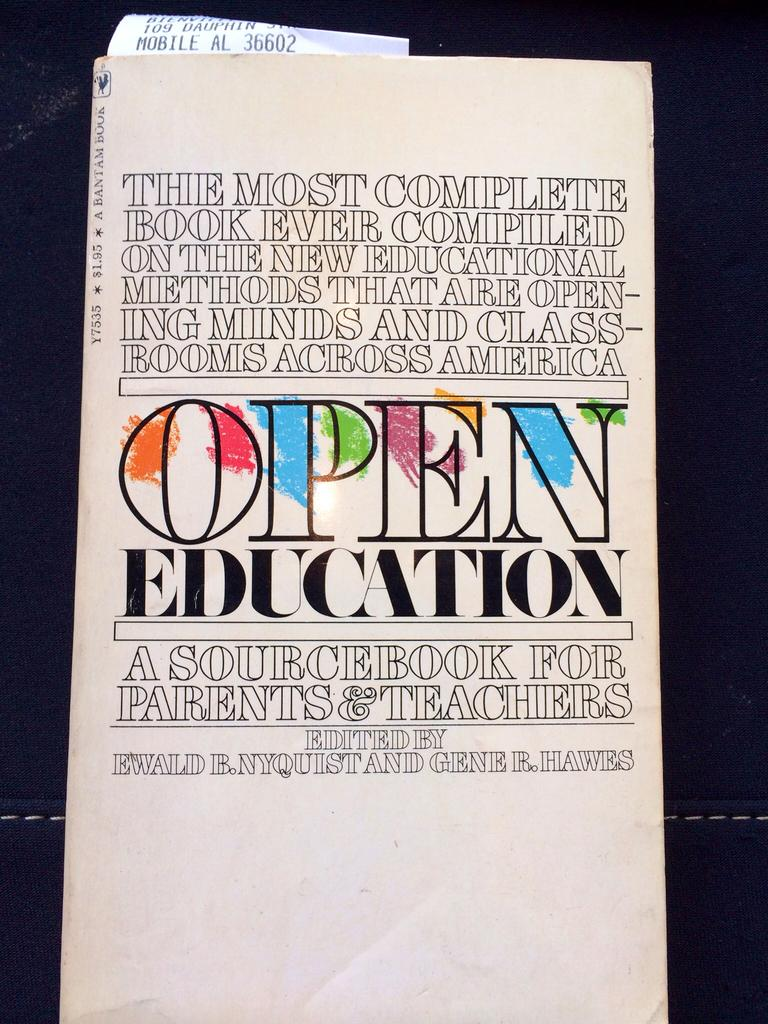<image>
Provide a brief description of the given image. A book titled Open Education has a receipt sticking out from the top. 